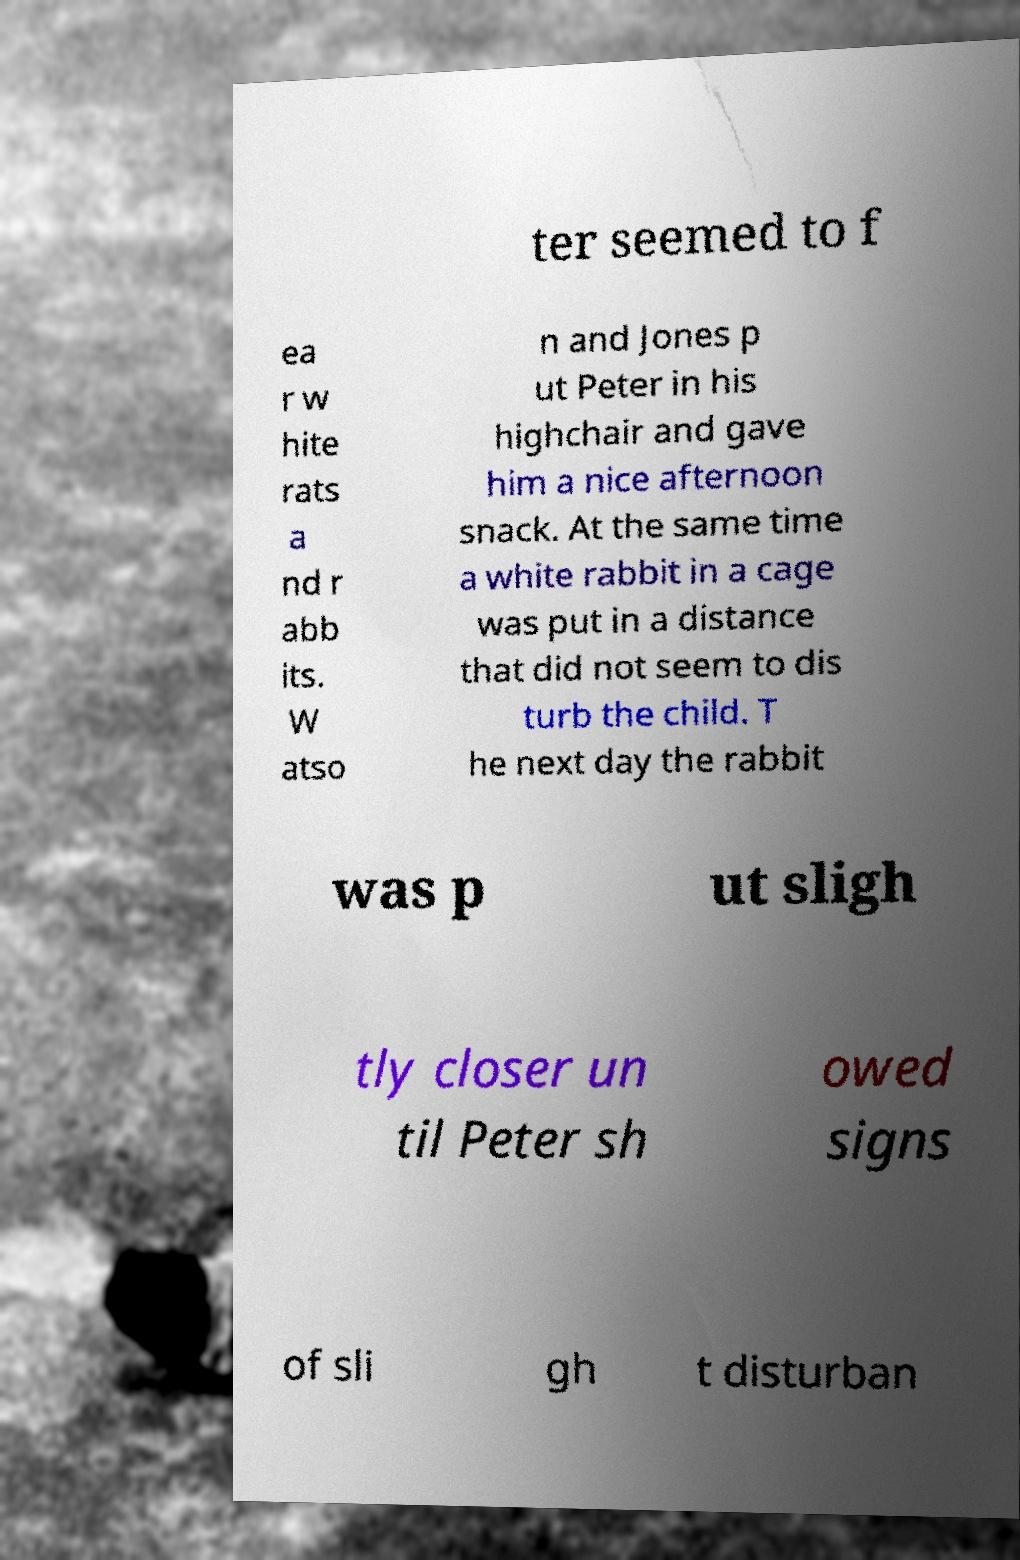Could you extract and type out the text from this image? ter seemed to f ea r w hite rats a nd r abb its. W atso n and Jones p ut Peter in his highchair and gave him a nice afternoon snack. At the same time a white rabbit in a cage was put in a distance that did not seem to dis turb the child. T he next day the rabbit was p ut sligh tly closer un til Peter sh owed signs of sli gh t disturban 